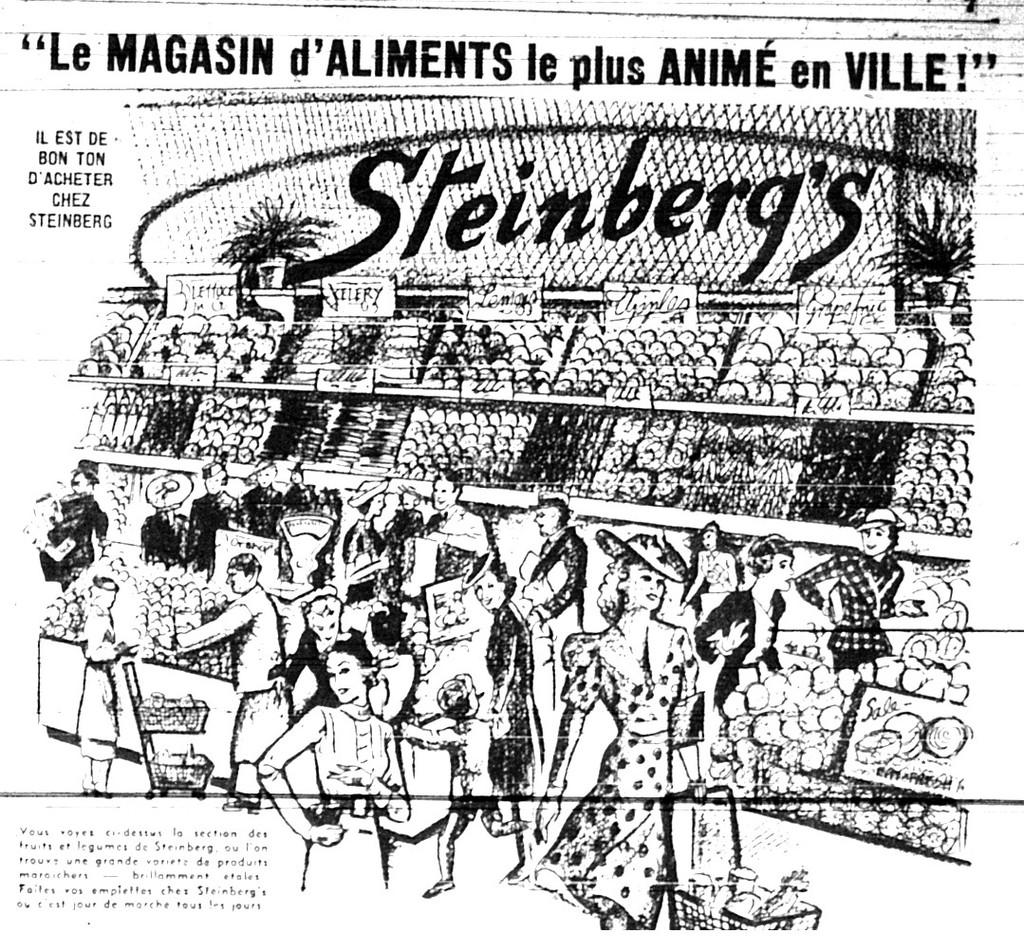What type of visual is the image? The image is a poster. What can be seen on the poster? There are depictions of people on the poster, along with objects behind them. Can you describe the objects behind the people? There are boards visible on the poster. What else can be seen on the poster? Flower pots are present on racks in the poster. Is there any text on the poster? Yes, there is some text on the poster. What type of weather is depicted in the poster? The poster does not depict any weather conditions; it features people, objects, and text. What is the purpose of the journey shown in the poster? There is no journey depicted in the poster; it is a static image with people, objects, and text. 